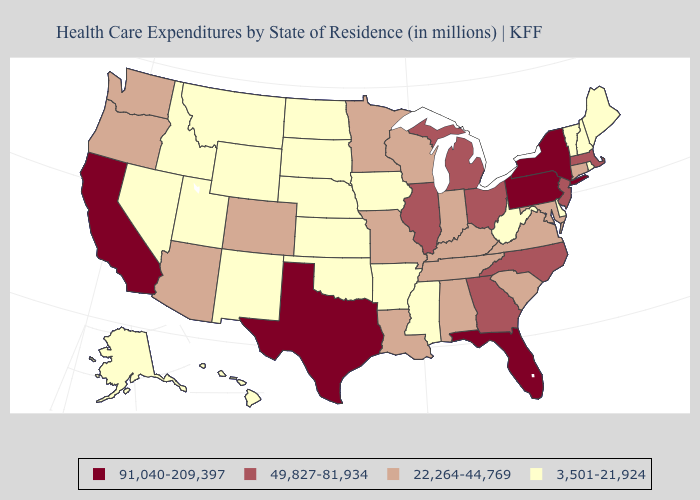Among the states that border Delaware , which have the highest value?
Keep it brief. Pennsylvania. What is the value of Nebraska?
Keep it brief. 3,501-21,924. Which states hav the highest value in the Northeast?
Concise answer only. New York, Pennsylvania. What is the lowest value in the MidWest?
Write a very short answer. 3,501-21,924. What is the lowest value in the USA?
Keep it brief. 3,501-21,924. Is the legend a continuous bar?
Answer briefly. No. Name the states that have a value in the range 22,264-44,769?
Answer briefly. Alabama, Arizona, Colorado, Connecticut, Indiana, Kentucky, Louisiana, Maryland, Minnesota, Missouri, Oregon, South Carolina, Tennessee, Virginia, Washington, Wisconsin. Among the states that border Oklahoma , which have the highest value?
Write a very short answer. Texas. Is the legend a continuous bar?
Short answer required. No. Among the states that border Nebraska , which have the highest value?
Keep it brief. Colorado, Missouri. Among the states that border Kansas , which have the lowest value?
Answer briefly. Nebraska, Oklahoma. Name the states that have a value in the range 3,501-21,924?
Concise answer only. Alaska, Arkansas, Delaware, Hawaii, Idaho, Iowa, Kansas, Maine, Mississippi, Montana, Nebraska, Nevada, New Hampshire, New Mexico, North Dakota, Oklahoma, Rhode Island, South Dakota, Utah, Vermont, West Virginia, Wyoming. What is the value of Utah?
Keep it brief. 3,501-21,924. Is the legend a continuous bar?
Answer briefly. No. What is the value of California?
Quick response, please. 91,040-209,397. 